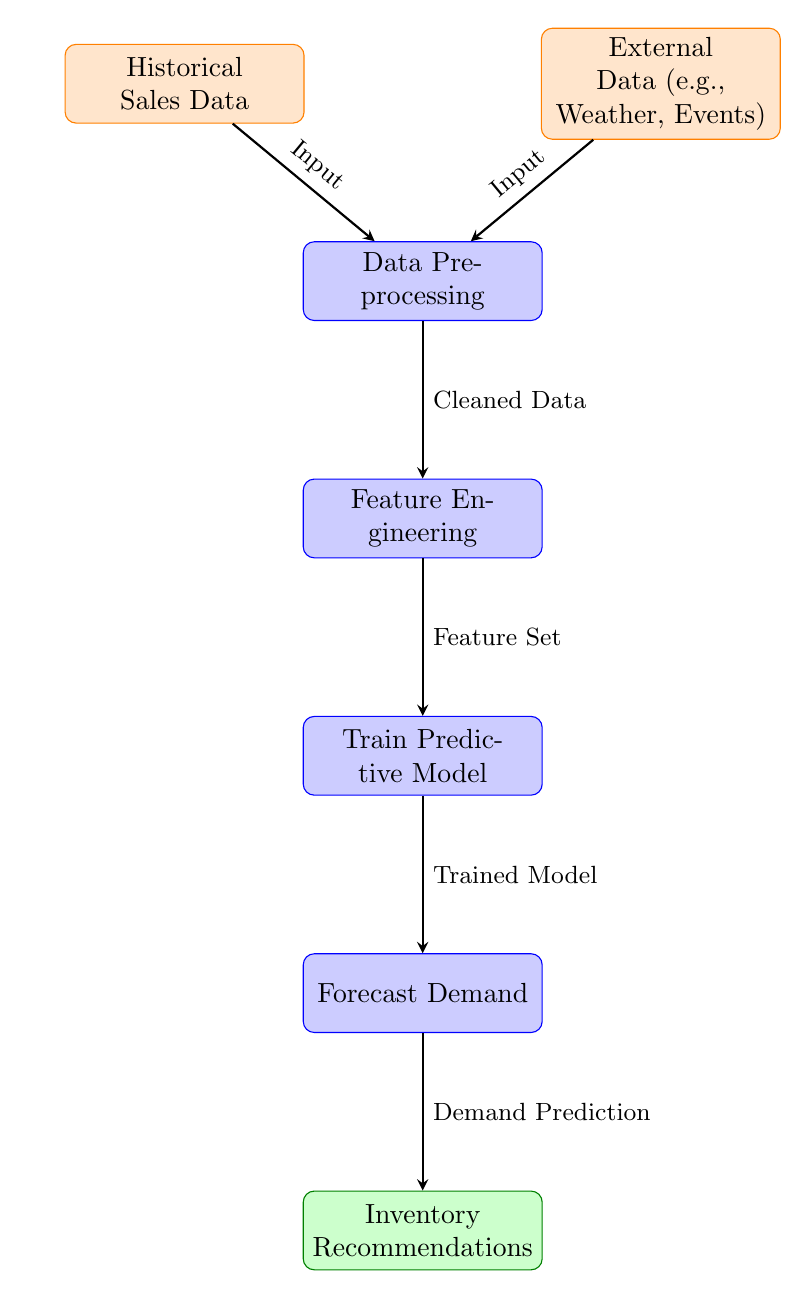What are the inputs to the data preprocessing node? The inputs to the data preprocessing node are the historical sales data and external data. These inputs are shown as arrows leading into the data preprocessing node from the corresponding data nodes above it.
Answer: Historical Sales Data, External Data How many processes are depicted in the diagram? The diagram includes five process nodes: Data Preprocessing, Feature Engineering, Train Predictive Model, Forecast Demand, and Inventory Recommendations. These nodes are visually represented in a vertical sequence.
Answer: Five Which node comes after feature engineering? The node that comes after feature engineering is "Train Predictive Model." This can be determined by following the arrows from the feature engineering node downward to the next process node.
Answer: Train Predictive Model What type of data is used in the feature engineering node? The type of data used in the feature engineering node is "Cleaned Data." This is indicated by the label on the arrow that shows the output from the data preprocessing to the feature engineering node.
Answer: Cleaned Data What is the final output of the diagram? The final output of the diagram is "Inventory Recommendations." This is the last node in the flow sequence, receiving input from the forecast demand node.
Answer: Inventory Recommendations What links the external data and historical sales data to the data preprocessing node? The external data and historical sales data are linked to the data preprocessing node by arrows labeled as "Input." Each arrow indicates the direction of data flow into the preprocessing step.
Answer: Input How does the trained model contribute to the diagram's output? The trained model contributes by providing "Demand Prediction" to the forecast demand node, which then leads to inventory recommendations as the end output. The flow indicates that the model is critical for producing predictions that influence inventory decisions.
Answer: Demand Prediction What type of data influences inventory levels based on the entire process? The type of data that influences inventory levels based on the entire process includes historical sales data and external data. They flow into the data preprocessing, leading to eventual recommendations on inventory levels.
Answer: Historical Sales Data, External Data 